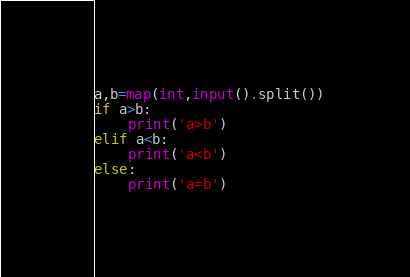<code> <loc_0><loc_0><loc_500><loc_500><_Python_>a,b=map(int,input().split())
if a>b:
    print('a>b')
elif a<b:
    print('a<b')
else:
    print('a=b')</code> 